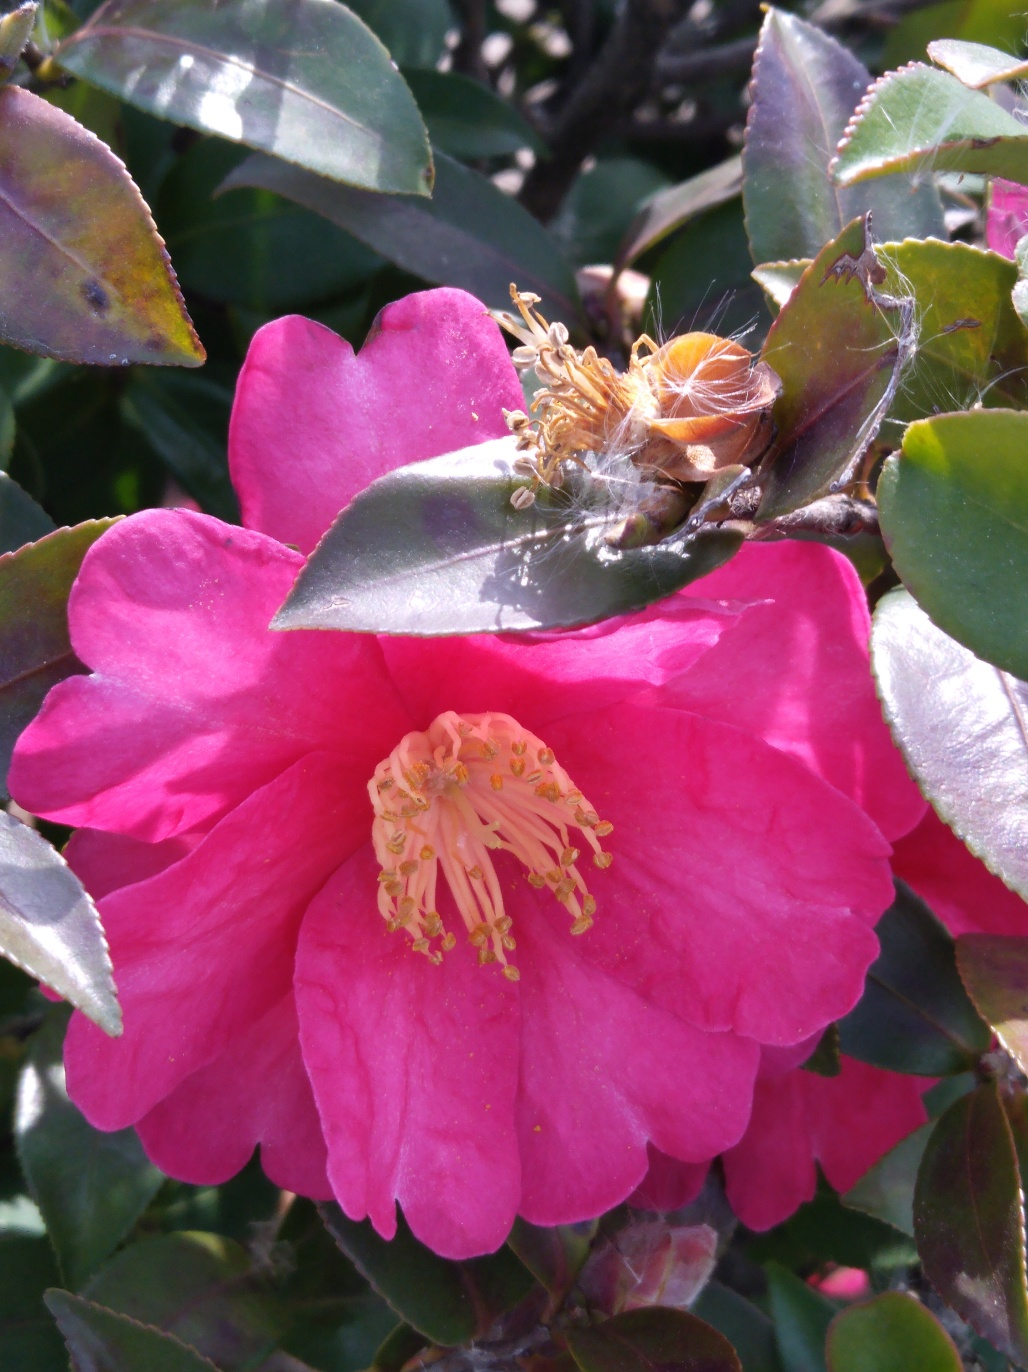What does the presence of a spider web on a flower tell us about the environment? The presence of a spider web indicates a thriving micro-ecosystem. Spiders typically weave their webs where they can catch prey easily, suggesting that this area has a good population of insects, which in turn suggests a healthy local environment. 